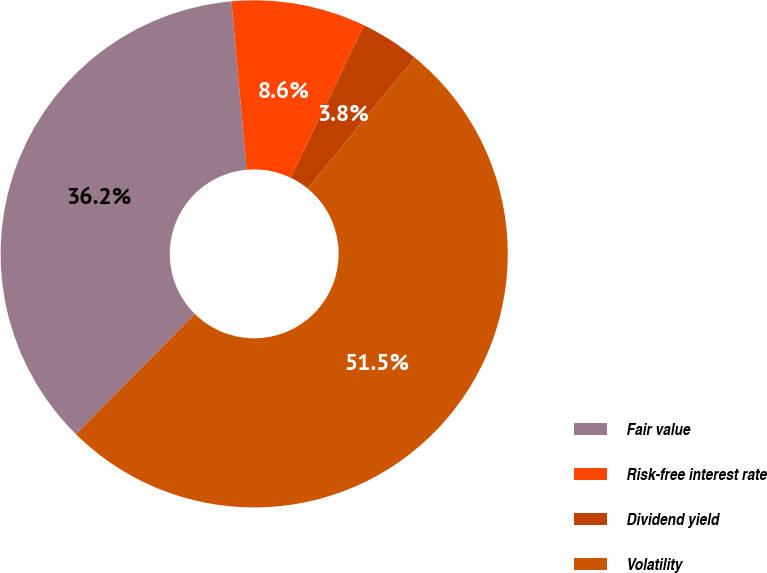Convert chart to OTSL. <chart><loc_0><loc_0><loc_500><loc_500><pie_chart><fcel>Fair value<fcel>Risk-free interest rate<fcel>Dividend yield<fcel>Volatility<nl><fcel>36.15%<fcel>8.56%<fcel>3.79%<fcel>51.5%<nl></chart> 